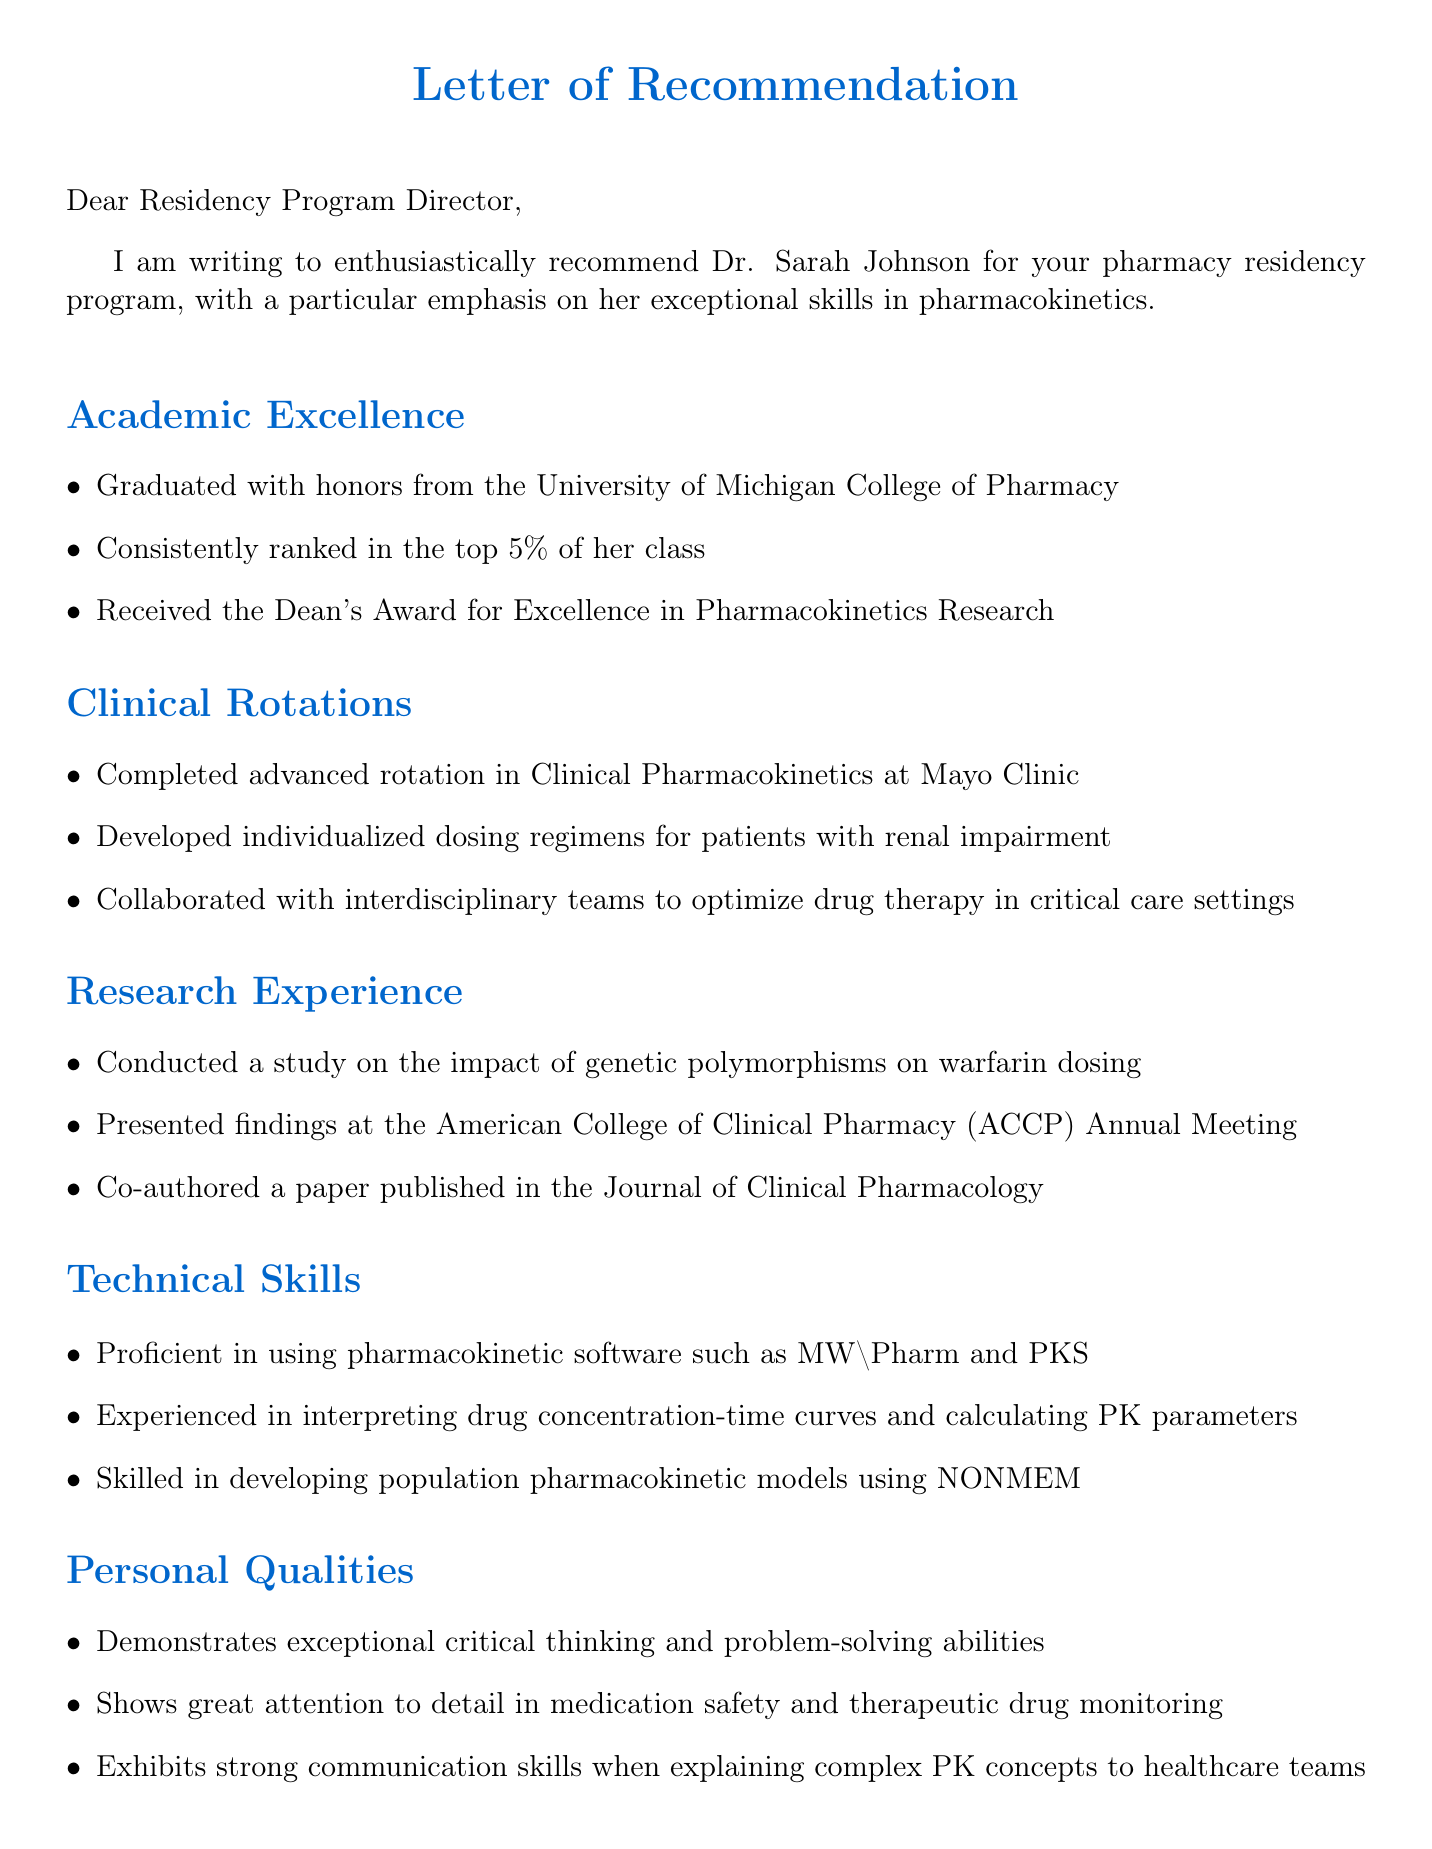What is the candidate's name? The candidate's name is explicitly mentioned in the document as Dr. Sarah Johnson.
Answer: Dr. Sarah Johnson What degree does the candidate hold? The degree of the candidate is specified in the document, which states that she holds a PharmD.
Answer: PharmD Which university did the candidate graduate from? The document clearly states that the candidate graduated from the University of Michigan College of Pharmacy.
Answer: University of Michigan College of Pharmacy In what year did the candidate graduate? The graduation year of the candidate is provided in the document as 2023.
Answer: 2023 What award did the candidate receive? The document notes that the candidate received the Dean's Award for Excellence in Pharmacokinetics Research.
Answer: Dean's Award for Excellence in Pharmacokinetics Research Which institution is the writer associated with? The document specifies that the writer is affiliated with Mercy General Hospital.
Answer: Mercy General Hospital What is the writer's position? The writer's position is explicitly mentioned in the document as Clinical Pharmacy Specialist - Pharmacokinetics.
Answer: Clinical Pharmacy Specialist - Pharmacokinetics What kind of studies did the candidate conduct? The document details that the candidate conducted a study on the impact of genetic polymorphisms on warfarin dosing.
Answer: Study on the impact of genetic polymorphisms on warfarin dosing How does the writer describe the candidate's personal qualities? The document describes the candidate as demonstrating exceptional critical thinking and problem-solving abilities.
Answer: Exceptional critical thinking and problem-solving abilities What software is the candidate proficient in? The document states that the candidate is proficient in using pharmacokinetic software such as MW\Pharm and PKS.
Answer: MW\Pharm and PKS 